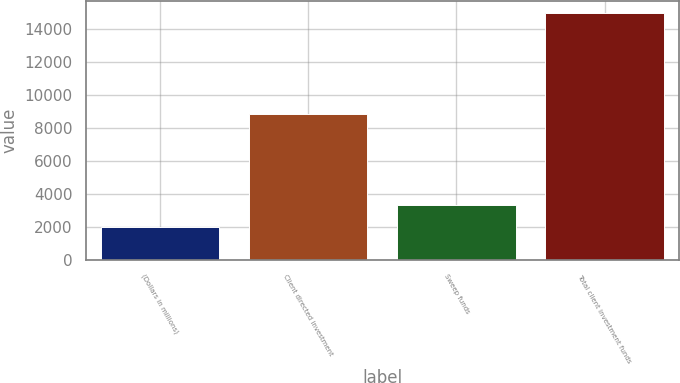<chart> <loc_0><loc_0><loc_500><loc_500><bar_chart><fcel>(Dollars in millions)<fcel>Client directed investment<fcel>Sweep funds<fcel>Total client investment funds<nl><fcel>2005<fcel>8863<fcel>3301.2<fcel>14967<nl></chart> 